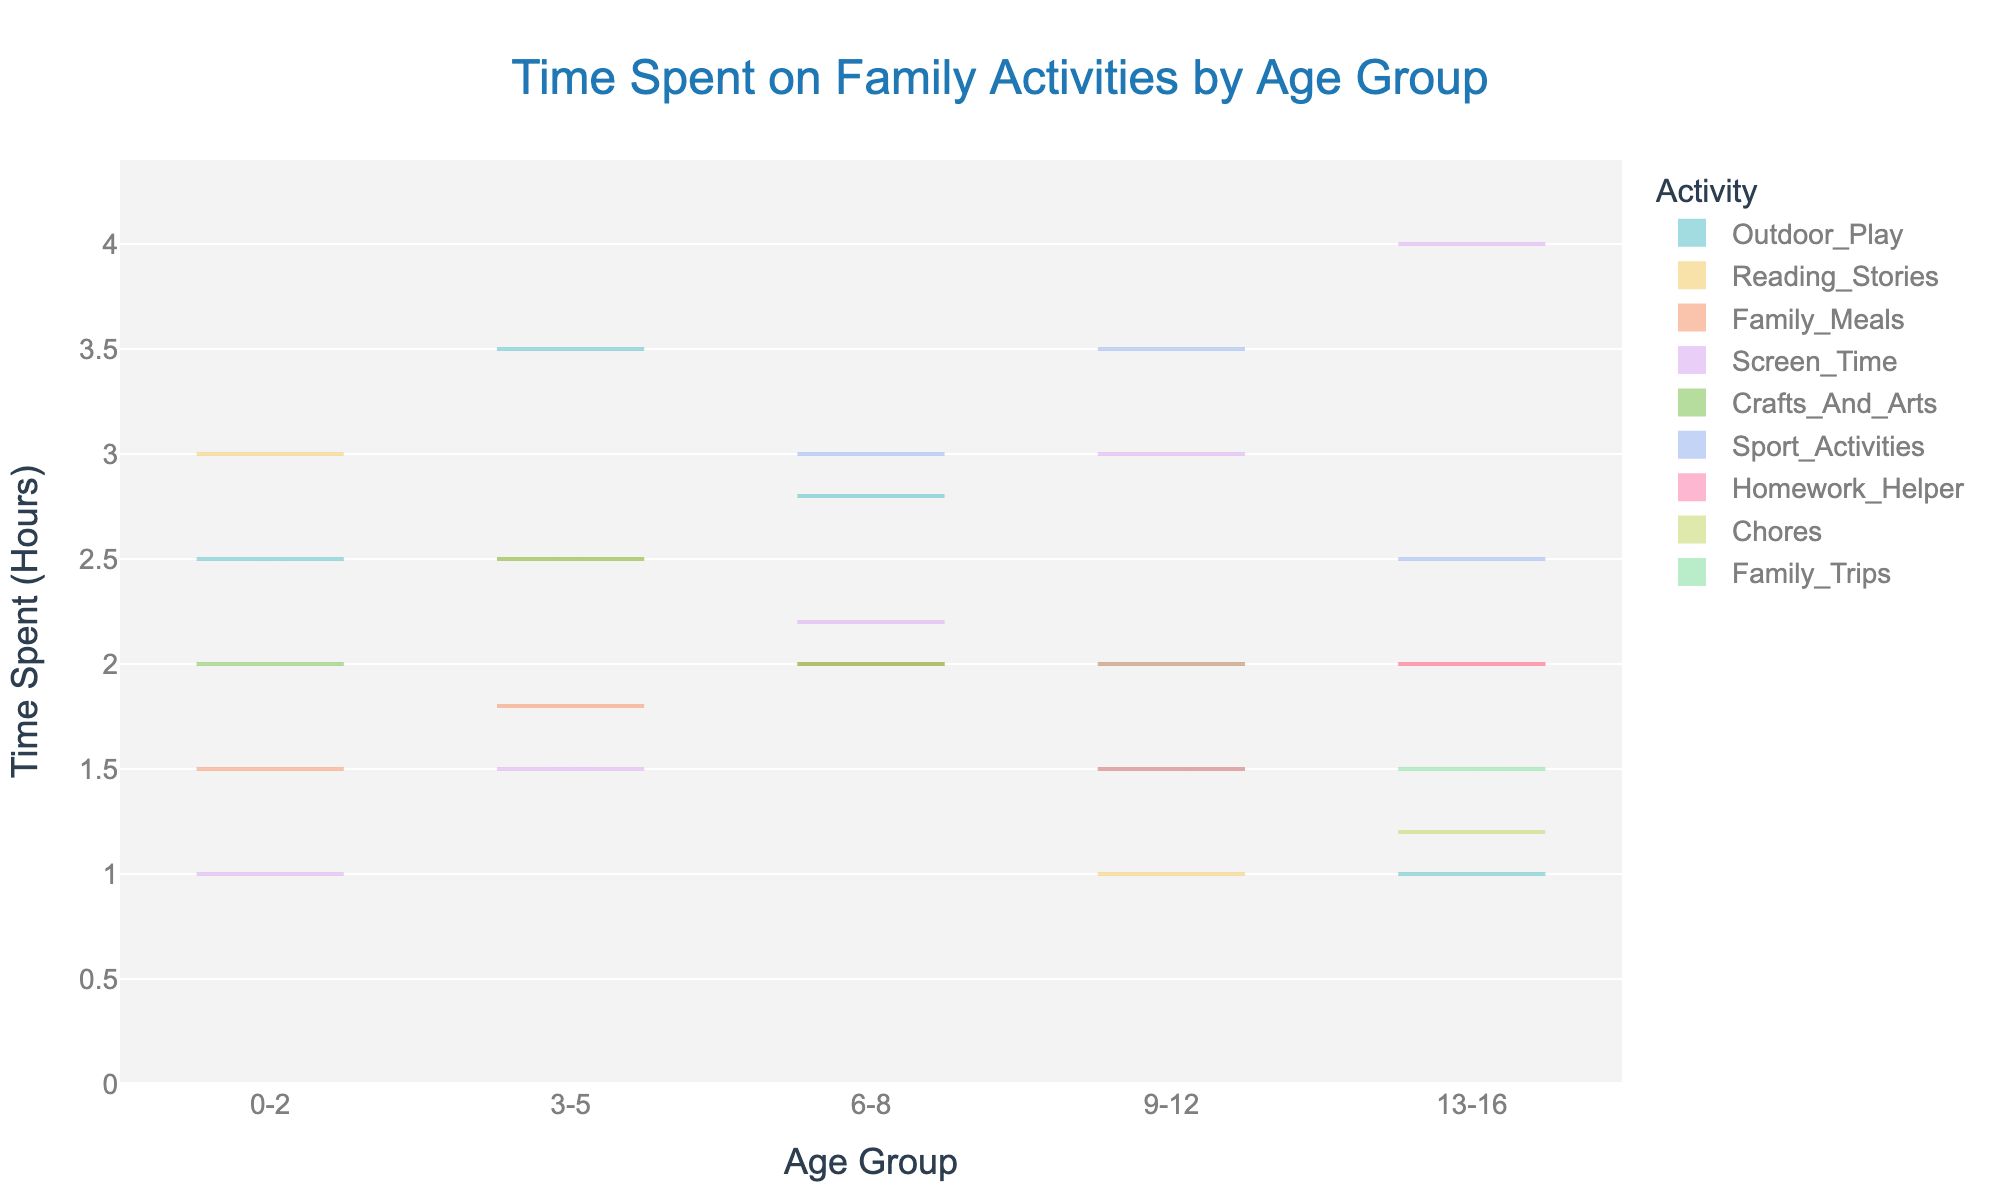What is the title of the chart? The title is located at the top center of the chart. It is set in a readable size and clear font.
Answer: Time Spent on Family Activities by Age Group Which age group spends the most time on screen activities? To answer this, observe the violin plot and box plot overlay. Specifically, look at the 'Screen_Time' activity for each age group and find the one with the highest values.
Answer: 13-16 What is the range of time spent on family meals for the age group 9-12? Refer to the violin plot for 'Family_Meals' in the 9-12 age group. The range is determined from the minimum to the maximum data points shown by the spread of the plot and confirmed by the box plot over it.
Answer: 2 hours Which activity shows the greatest variance in time spent for age group 3-5? Compare the width of the violin plots for all activities within the 3-5 age group. The activity with the widest plot exhibits the greatest variance.
Answer: Outdoor_Play Between which two age groups is there the biggest difference in median time spent on 'Outdoor_Play'? Observe the box plots for 'Outdoor_Play' across all age groups and identify the medians (typically the line in the box). Determine which age groups have the most significant difference.
Answer: 3-5 and 13-16 How does the median time spent on 'Family_Trips' for the age group 13-16 compare to the total median time spent on 'Family_Meals' across all ages? First, find the median for 'Family_Trips' in age group 13-16 from its box plot. Then, determine the median of all 'Family_Meals' across each age group and compare the two.
Answer: Family_Trips (13-16) is lower What's the average time spent on 'Crafts_And_Arts' for age groups 0-2 and 3-5 combined? Calculate the average time by summing the time spent values for 'Crafts_And_Arts' in both age groups and dividing by the number of values.
Answer: 2.25 hours In which activity do children aged 6-8 spend the least amount of time? Review the minimum values of all activities for the 6-8 age group. Identify the activity with the lowest minimum value.
Answer: Reading_Stories What is the interquartile range (IQR) for 'Sport_Activities' in age group 9-12? Locate the box plot for 'Sport_Activities' in the 9-12 age group. The IQR is the distance between the third quartile (Q3) and the first quartile (Q1).
Answer: 1.5 hours 